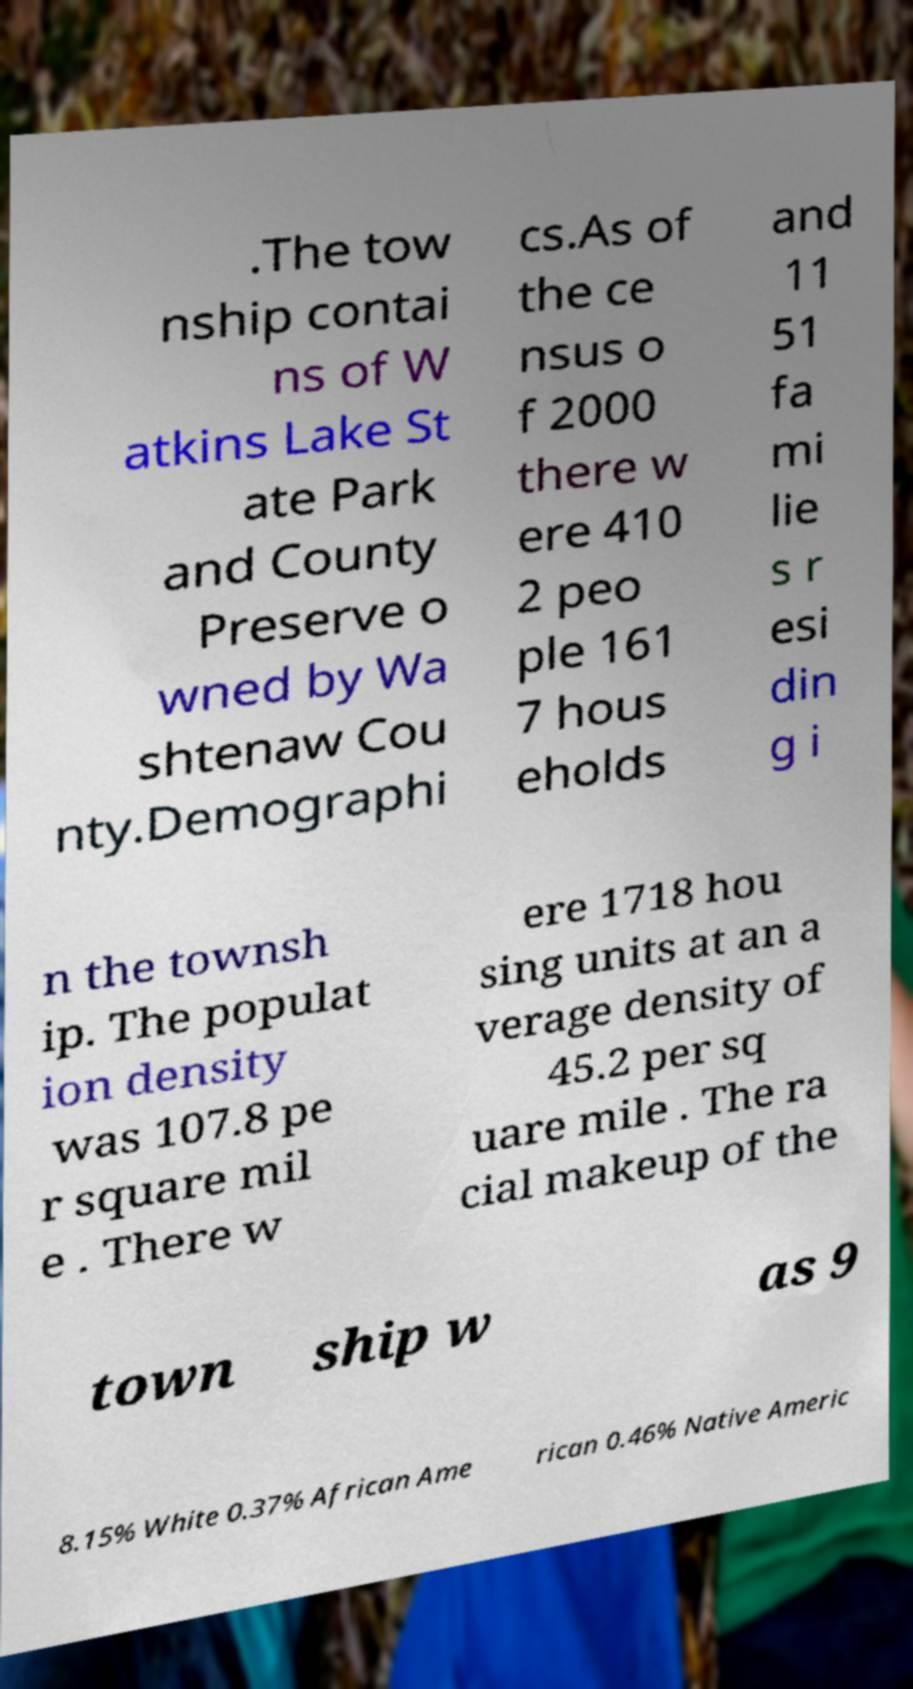What messages or text are displayed in this image? I need them in a readable, typed format. .The tow nship contai ns of W atkins Lake St ate Park and County Preserve o wned by Wa shtenaw Cou nty.Demographi cs.As of the ce nsus o f 2000 there w ere 410 2 peo ple 161 7 hous eholds and 11 51 fa mi lie s r esi din g i n the townsh ip. The populat ion density was 107.8 pe r square mil e . There w ere 1718 hou sing units at an a verage density of 45.2 per sq uare mile . The ra cial makeup of the town ship w as 9 8.15% White 0.37% African Ame rican 0.46% Native Americ 